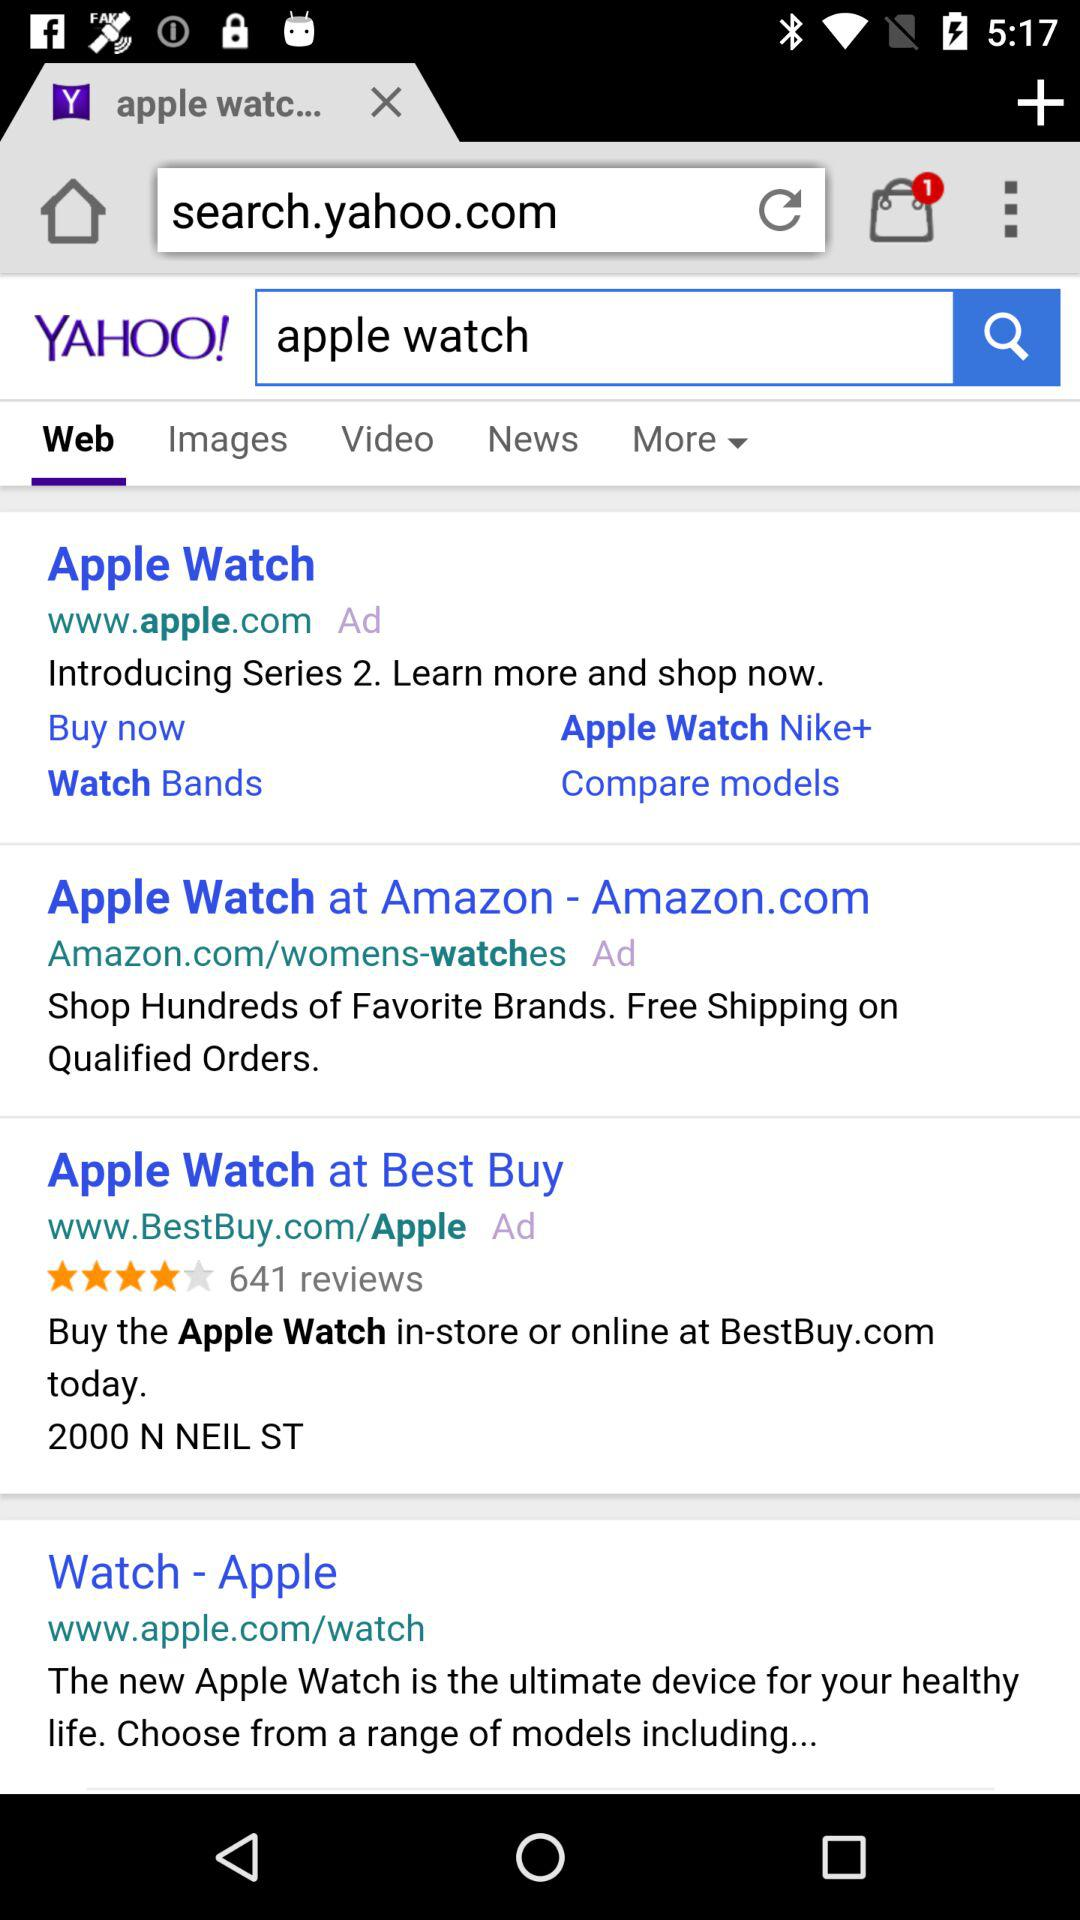What is the watch's brand name? The watch is of the "Apple" brand. 